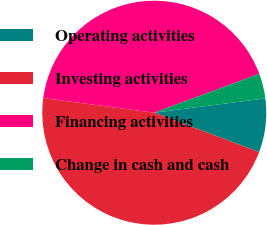Convert chart. <chart><loc_0><loc_0><loc_500><loc_500><pie_chart><fcel>Operating activities<fcel>Investing activities<fcel>Financing activities<fcel>Change in cash and cash<nl><fcel>7.76%<fcel>46.38%<fcel>42.24%<fcel>3.62%<nl></chart> 